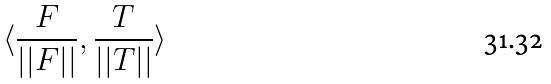Convert formula to latex. <formula><loc_0><loc_0><loc_500><loc_500>\langle \frac { F } { | | F | | } , \frac { T } { | | T | | } \rangle</formula> 